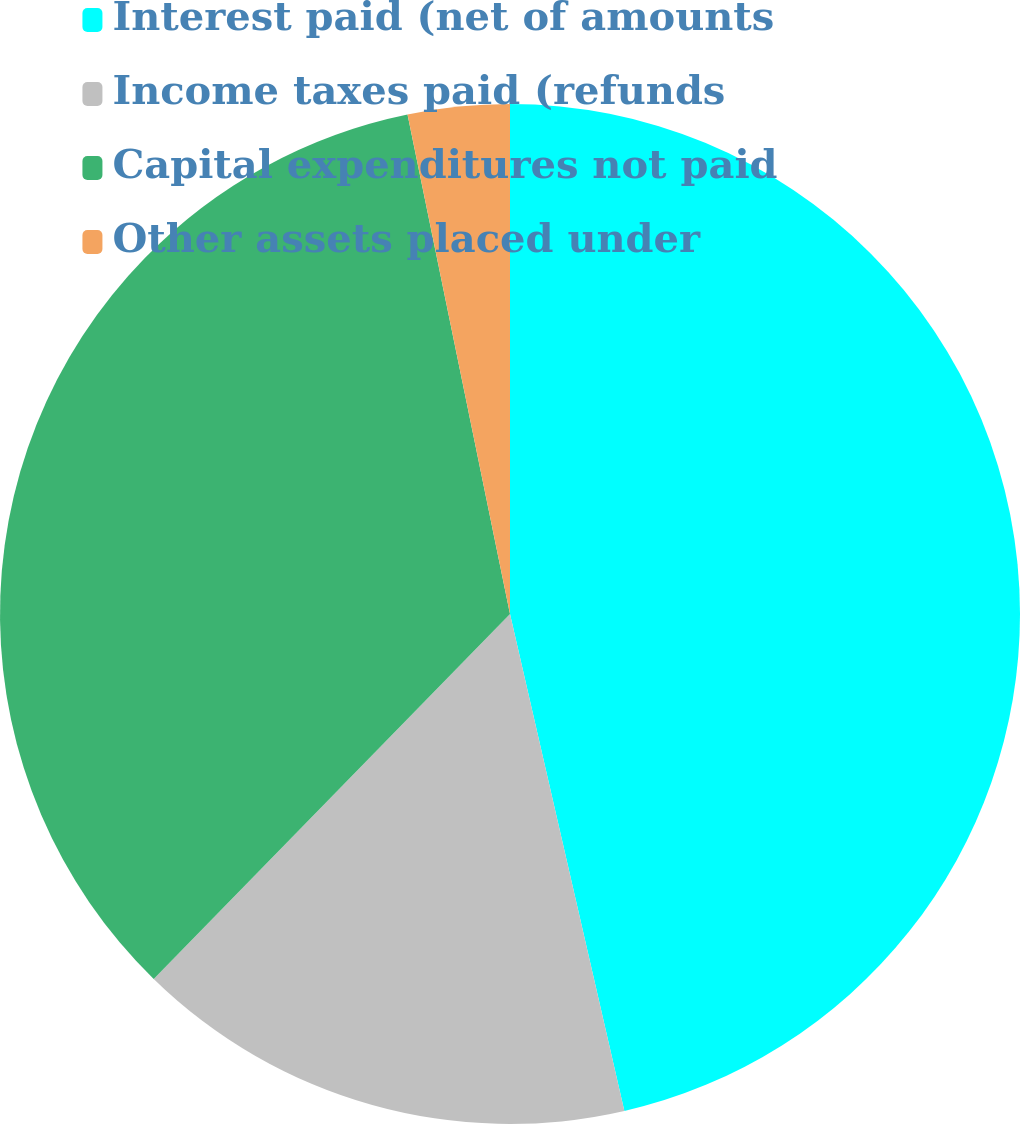<chart> <loc_0><loc_0><loc_500><loc_500><pie_chart><fcel>Interest paid (net of amounts<fcel>Income taxes paid (refunds<fcel>Capital expenditures not paid<fcel>Other assets placed under<nl><fcel>46.4%<fcel>15.91%<fcel>34.47%<fcel>3.22%<nl></chart> 